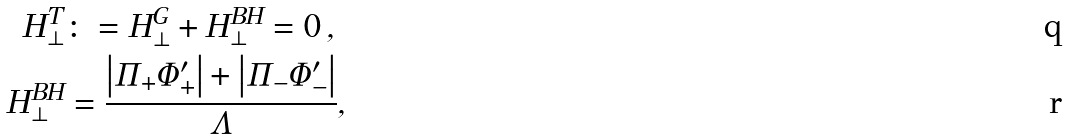<formula> <loc_0><loc_0><loc_500><loc_500>H _ { \bot } ^ { T } & \colon = H _ { \bot } ^ { G } + H _ { \bot } ^ { B H } = 0 \, , \\ H _ { \bot } ^ { B H } & = \frac { \left | \Pi _ { + } \Phi _ { + } ^ { \prime } \right | + \left | \Pi _ { - } \Phi _ { - } ^ { \prime } \right | } { \Lambda } ,</formula> 